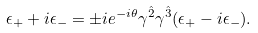Convert formula to latex. <formula><loc_0><loc_0><loc_500><loc_500>\epsilon _ { + } + i \epsilon _ { - } = \pm i e ^ { - i \theta } \gamma ^ { \hat { 2 } } \gamma ^ { \hat { 3 } } ( \epsilon _ { + } - i \epsilon _ { - } ) .</formula> 